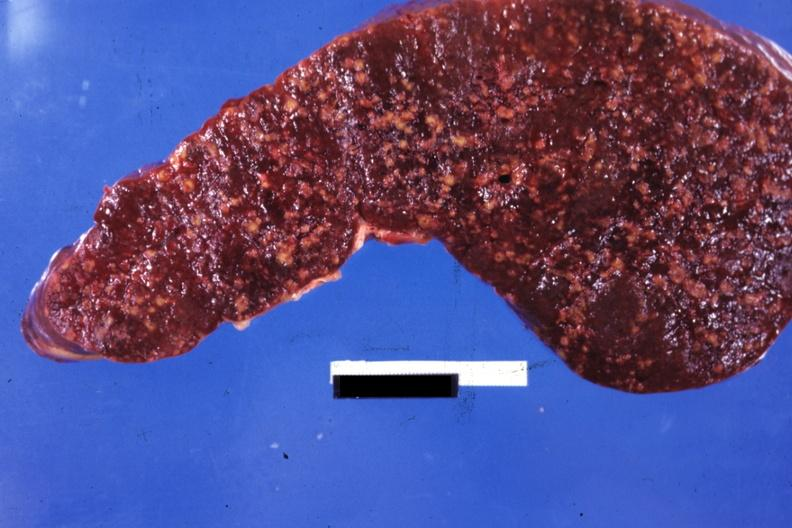s glioma present?
Answer the question using a single word or phrase. No 